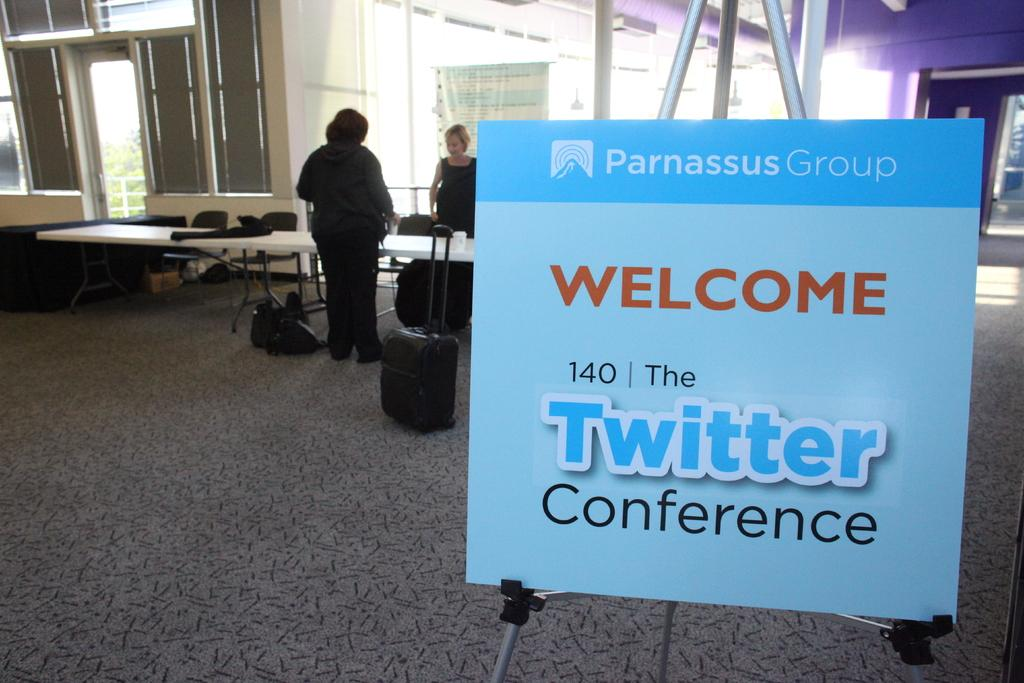What is the main object in the image? There is a board in the image. What is written on the board? "Welcome" and "Twitter" are written on the board. What can be seen in the background of the image? There are people, a table, and chairs in the background of the image. What type of wood is used to make the chairs in the image? There is no information about the type of wood used to make the chairs in the image. Additionally, the chairs themselves are not visible in the image, only the table in the background. 